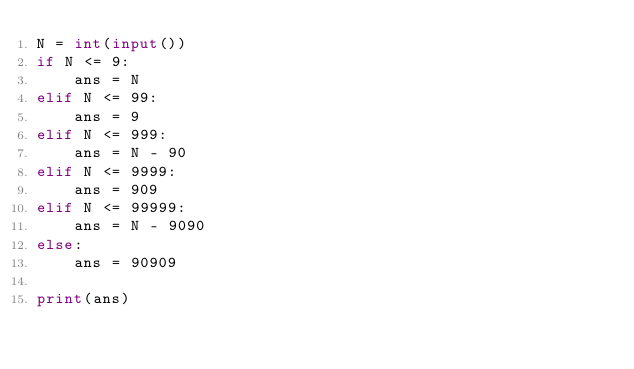Convert code to text. <code><loc_0><loc_0><loc_500><loc_500><_Python_>N = int(input())
if N <= 9:
    ans = N
elif N <= 99:
    ans = 9
elif N <= 999:
    ans = N - 90
elif N <= 9999:
    ans = 909
elif N <= 99999:
    ans = N - 9090
else:
    ans = 90909

print(ans)
</code> 